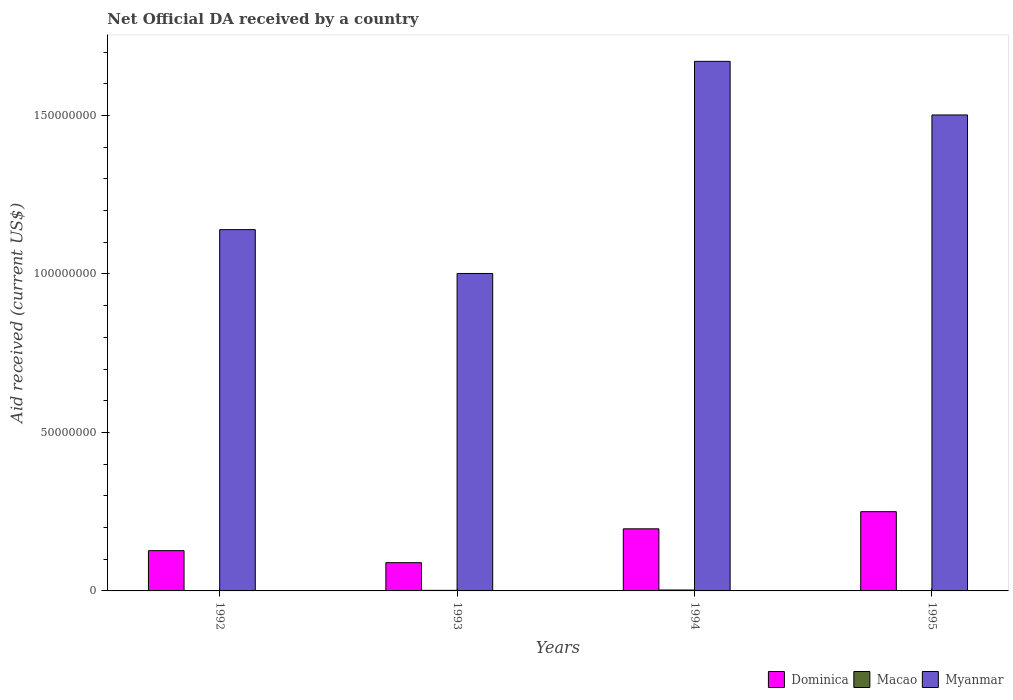How many bars are there on the 4th tick from the right?
Offer a terse response. 3. What is the net official development assistance aid received in Myanmar in 1995?
Give a very brief answer. 1.50e+08. Across all years, what is the maximum net official development assistance aid received in Macao?
Your response must be concise. 2.90e+05. Across all years, what is the minimum net official development assistance aid received in Myanmar?
Provide a succinct answer. 1.00e+08. What is the total net official development assistance aid received in Dominica in the graph?
Offer a terse response. 6.62e+07. What is the difference between the net official development assistance aid received in Myanmar in 1992 and that in 1994?
Keep it short and to the point. -5.31e+07. What is the difference between the net official development assistance aid received in Myanmar in 1993 and the net official development assistance aid received in Macao in 1994?
Your answer should be very brief. 9.99e+07. What is the average net official development assistance aid received in Myanmar per year?
Give a very brief answer. 1.33e+08. In the year 1993, what is the difference between the net official development assistance aid received in Dominica and net official development assistance aid received in Myanmar?
Your response must be concise. -9.12e+07. In how many years, is the net official development assistance aid received in Dominica greater than 90000000 US$?
Ensure brevity in your answer.  0. What is the ratio of the net official development assistance aid received in Myanmar in 1992 to that in 1994?
Keep it short and to the point. 0.68. Is the difference between the net official development assistance aid received in Dominica in 1993 and 1994 greater than the difference between the net official development assistance aid received in Myanmar in 1993 and 1994?
Your answer should be very brief. Yes. What is the difference between the highest and the second highest net official development assistance aid received in Myanmar?
Your response must be concise. 1.69e+07. What is the difference between the highest and the lowest net official development assistance aid received in Myanmar?
Give a very brief answer. 6.69e+07. In how many years, is the net official development assistance aid received in Macao greater than the average net official development assistance aid received in Macao taken over all years?
Keep it short and to the point. 2. Is it the case that in every year, the sum of the net official development assistance aid received in Dominica and net official development assistance aid received in Macao is greater than the net official development assistance aid received in Myanmar?
Ensure brevity in your answer.  No. How many bars are there?
Make the answer very short. 11. Are all the bars in the graph horizontal?
Make the answer very short. No. How many years are there in the graph?
Offer a very short reply. 4. Are the values on the major ticks of Y-axis written in scientific E-notation?
Give a very brief answer. No. How are the legend labels stacked?
Offer a very short reply. Horizontal. What is the title of the graph?
Offer a very short reply. Net Official DA received by a country. Does "Andorra" appear as one of the legend labels in the graph?
Your answer should be very brief. No. What is the label or title of the Y-axis?
Ensure brevity in your answer.  Aid received (current US$). What is the Aid received (current US$) of Dominica in 1992?
Keep it short and to the point. 1.27e+07. What is the Aid received (current US$) in Myanmar in 1992?
Your response must be concise. 1.14e+08. What is the Aid received (current US$) in Dominica in 1993?
Your answer should be very brief. 8.91e+06. What is the Aid received (current US$) of Myanmar in 1993?
Offer a terse response. 1.00e+08. What is the Aid received (current US$) in Dominica in 1994?
Provide a short and direct response. 1.96e+07. What is the Aid received (current US$) in Myanmar in 1994?
Your answer should be compact. 1.67e+08. What is the Aid received (current US$) in Dominica in 1995?
Keep it short and to the point. 2.50e+07. What is the Aid received (current US$) of Myanmar in 1995?
Ensure brevity in your answer.  1.50e+08. Across all years, what is the maximum Aid received (current US$) of Dominica?
Provide a short and direct response. 2.50e+07. Across all years, what is the maximum Aid received (current US$) in Myanmar?
Keep it short and to the point. 1.67e+08. Across all years, what is the minimum Aid received (current US$) in Dominica?
Your answer should be compact. 8.91e+06. Across all years, what is the minimum Aid received (current US$) in Myanmar?
Ensure brevity in your answer.  1.00e+08. What is the total Aid received (current US$) in Dominica in the graph?
Ensure brevity in your answer.  6.62e+07. What is the total Aid received (current US$) in Macao in the graph?
Ensure brevity in your answer.  6.00e+05. What is the total Aid received (current US$) of Myanmar in the graph?
Provide a succinct answer. 5.31e+08. What is the difference between the Aid received (current US$) in Dominica in 1992 and that in 1993?
Ensure brevity in your answer.  3.79e+06. What is the difference between the Aid received (current US$) of Macao in 1992 and that in 1993?
Your answer should be very brief. -5.00e+04. What is the difference between the Aid received (current US$) in Myanmar in 1992 and that in 1993?
Your answer should be very brief. 1.38e+07. What is the difference between the Aid received (current US$) in Dominica in 1992 and that in 1994?
Provide a short and direct response. -6.89e+06. What is the difference between the Aid received (current US$) in Myanmar in 1992 and that in 1994?
Your response must be concise. -5.31e+07. What is the difference between the Aid received (current US$) of Dominica in 1992 and that in 1995?
Ensure brevity in your answer.  -1.23e+07. What is the difference between the Aid received (current US$) in Myanmar in 1992 and that in 1995?
Your response must be concise. -3.62e+07. What is the difference between the Aid received (current US$) of Dominica in 1993 and that in 1994?
Keep it short and to the point. -1.07e+07. What is the difference between the Aid received (current US$) of Macao in 1993 and that in 1994?
Your response must be concise. -1.10e+05. What is the difference between the Aid received (current US$) of Myanmar in 1993 and that in 1994?
Offer a very short reply. -6.69e+07. What is the difference between the Aid received (current US$) of Dominica in 1993 and that in 1995?
Keep it short and to the point. -1.61e+07. What is the difference between the Aid received (current US$) in Myanmar in 1993 and that in 1995?
Offer a terse response. -5.00e+07. What is the difference between the Aid received (current US$) of Dominica in 1994 and that in 1995?
Ensure brevity in your answer.  -5.41e+06. What is the difference between the Aid received (current US$) in Myanmar in 1994 and that in 1995?
Make the answer very short. 1.69e+07. What is the difference between the Aid received (current US$) of Dominica in 1992 and the Aid received (current US$) of Macao in 1993?
Offer a very short reply. 1.25e+07. What is the difference between the Aid received (current US$) of Dominica in 1992 and the Aid received (current US$) of Myanmar in 1993?
Keep it short and to the point. -8.74e+07. What is the difference between the Aid received (current US$) of Macao in 1992 and the Aid received (current US$) of Myanmar in 1993?
Your response must be concise. -1.00e+08. What is the difference between the Aid received (current US$) in Dominica in 1992 and the Aid received (current US$) in Macao in 1994?
Your answer should be very brief. 1.24e+07. What is the difference between the Aid received (current US$) in Dominica in 1992 and the Aid received (current US$) in Myanmar in 1994?
Your answer should be compact. -1.54e+08. What is the difference between the Aid received (current US$) in Macao in 1992 and the Aid received (current US$) in Myanmar in 1994?
Provide a succinct answer. -1.67e+08. What is the difference between the Aid received (current US$) of Dominica in 1992 and the Aid received (current US$) of Myanmar in 1995?
Your answer should be very brief. -1.37e+08. What is the difference between the Aid received (current US$) in Macao in 1992 and the Aid received (current US$) in Myanmar in 1995?
Give a very brief answer. -1.50e+08. What is the difference between the Aid received (current US$) in Dominica in 1993 and the Aid received (current US$) in Macao in 1994?
Make the answer very short. 8.62e+06. What is the difference between the Aid received (current US$) of Dominica in 1993 and the Aid received (current US$) of Myanmar in 1994?
Ensure brevity in your answer.  -1.58e+08. What is the difference between the Aid received (current US$) in Macao in 1993 and the Aid received (current US$) in Myanmar in 1994?
Provide a succinct answer. -1.67e+08. What is the difference between the Aid received (current US$) of Dominica in 1993 and the Aid received (current US$) of Myanmar in 1995?
Provide a succinct answer. -1.41e+08. What is the difference between the Aid received (current US$) of Macao in 1993 and the Aid received (current US$) of Myanmar in 1995?
Provide a succinct answer. -1.50e+08. What is the difference between the Aid received (current US$) of Dominica in 1994 and the Aid received (current US$) of Myanmar in 1995?
Make the answer very short. -1.31e+08. What is the difference between the Aid received (current US$) of Macao in 1994 and the Aid received (current US$) of Myanmar in 1995?
Offer a very short reply. -1.50e+08. What is the average Aid received (current US$) in Dominica per year?
Make the answer very short. 1.66e+07. What is the average Aid received (current US$) in Macao per year?
Provide a succinct answer. 1.50e+05. What is the average Aid received (current US$) in Myanmar per year?
Your response must be concise. 1.33e+08. In the year 1992, what is the difference between the Aid received (current US$) in Dominica and Aid received (current US$) in Macao?
Offer a very short reply. 1.26e+07. In the year 1992, what is the difference between the Aid received (current US$) of Dominica and Aid received (current US$) of Myanmar?
Offer a very short reply. -1.01e+08. In the year 1992, what is the difference between the Aid received (current US$) in Macao and Aid received (current US$) in Myanmar?
Keep it short and to the point. -1.14e+08. In the year 1993, what is the difference between the Aid received (current US$) in Dominica and Aid received (current US$) in Macao?
Give a very brief answer. 8.73e+06. In the year 1993, what is the difference between the Aid received (current US$) of Dominica and Aid received (current US$) of Myanmar?
Offer a terse response. -9.12e+07. In the year 1993, what is the difference between the Aid received (current US$) of Macao and Aid received (current US$) of Myanmar?
Your response must be concise. -1.00e+08. In the year 1994, what is the difference between the Aid received (current US$) in Dominica and Aid received (current US$) in Macao?
Your answer should be very brief. 1.93e+07. In the year 1994, what is the difference between the Aid received (current US$) in Dominica and Aid received (current US$) in Myanmar?
Provide a short and direct response. -1.47e+08. In the year 1994, what is the difference between the Aid received (current US$) of Macao and Aid received (current US$) of Myanmar?
Offer a terse response. -1.67e+08. In the year 1995, what is the difference between the Aid received (current US$) in Dominica and Aid received (current US$) in Myanmar?
Your response must be concise. -1.25e+08. What is the ratio of the Aid received (current US$) of Dominica in 1992 to that in 1993?
Your response must be concise. 1.43. What is the ratio of the Aid received (current US$) in Macao in 1992 to that in 1993?
Keep it short and to the point. 0.72. What is the ratio of the Aid received (current US$) in Myanmar in 1992 to that in 1993?
Provide a short and direct response. 1.14. What is the ratio of the Aid received (current US$) of Dominica in 1992 to that in 1994?
Your answer should be very brief. 0.65. What is the ratio of the Aid received (current US$) of Macao in 1992 to that in 1994?
Ensure brevity in your answer.  0.45. What is the ratio of the Aid received (current US$) in Myanmar in 1992 to that in 1994?
Your answer should be very brief. 0.68. What is the ratio of the Aid received (current US$) in Dominica in 1992 to that in 1995?
Offer a very short reply. 0.51. What is the ratio of the Aid received (current US$) of Myanmar in 1992 to that in 1995?
Provide a short and direct response. 0.76. What is the ratio of the Aid received (current US$) in Dominica in 1993 to that in 1994?
Your response must be concise. 0.45. What is the ratio of the Aid received (current US$) of Macao in 1993 to that in 1994?
Your answer should be very brief. 0.62. What is the ratio of the Aid received (current US$) of Myanmar in 1993 to that in 1994?
Your response must be concise. 0.6. What is the ratio of the Aid received (current US$) of Dominica in 1993 to that in 1995?
Offer a terse response. 0.36. What is the ratio of the Aid received (current US$) in Myanmar in 1993 to that in 1995?
Make the answer very short. 0.67. What is the ratio of the Aid received (current US$) of Dominica in 1994 to that in 1995?
Your answer should be compact. 0.78. What is the ratio of the Aid received (current US$) in Myanmar in 1994 to that in 1995?
Offer a very short reply. 1.11. What is the difference between the highest and the second highest Aid received (current US$) of Dominica?
Your answer should be very brief. 5.41e+06. What is the difference between the highest and the second highest Aid received (current US$) of Macao?
Your answer should be very brief. 1.10e+05. What is the difference between the highest and the second highest Aid received (current US$) of Myanmar?
Your answer should be very brief. 1.69e+07. What is the difference between the highest and the lowest Aid received (current US$) in Dominica?
Provide a short and direct response. 1.61e+07. What is the difference between the highest and the lowest Aid received (current US$) of Macao?
Your answer should be compact. 2.90e+05. What is the difference between the highest and the lowest Aid received (current US$) of Myanmar?
Offer a very short reply. 6.69e+07. 